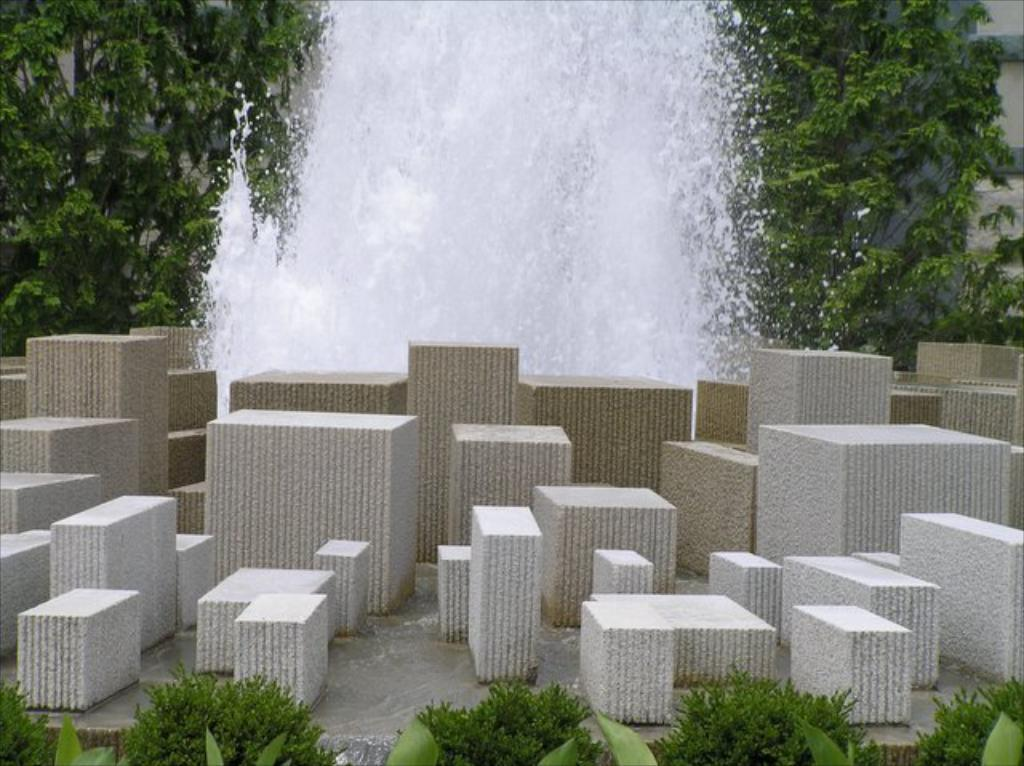What color are the objects in the image? The objects in the image are white. What can be seen in the background of the image? There is water and trees visible in the background of the image. What type of meal is being prepared in the image? There is no meal preparation visible in the image. Can you see any strings attached to the objects in the image? There are no strings visible in the image. 